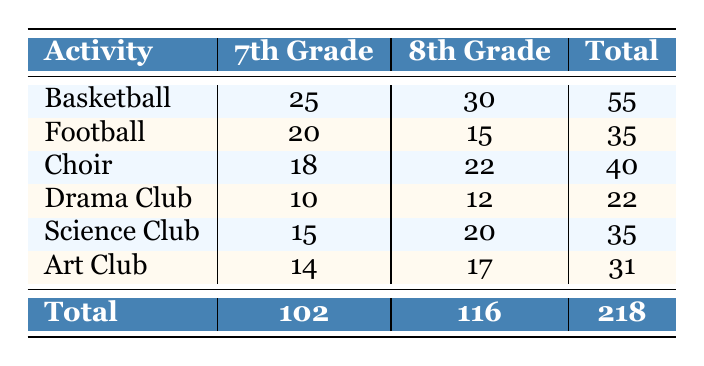What is the total participation count for the Basketball activity? To find the total participation count for Basketball, refer to the table and find the values for both grades. In the 7th grade, the participation count is 25, and in the 8th grade, it is 30. Therefore, the total participation count is 25 + 30 = 55.
Answer: 55 How many students in total participated in extracurricular activities in the 7th Grade? To find the total participation count for the 7th Grade, sum up the participation counts for all listed activities at that grade level. The counts are: Basketball (25), Football (20), Choir (18), Drama Club (10), Science Club (15), and Art Club (14). Adding these gives 25 + 20 + 18 + 10 + 15 + 14 = 102.
Answer: 102 Is there more total participation in the 8th Grade compared to the 7th Grade? To determine this, compare the total participation counts for both grades. The total for the 8th Grade is 116, and for the 7th Grade, it is 102. Since 116 is greater than 102, the statement is true.
Answer: Yes What is the average participation count for the Drama Club across both grades? To calculate the average, first find the total participation count for the Drama Club, which is 10 for 7th Grade and 12 for 8th Grade. The total is 10 + 12 = 22. There are 2 grades, so to find the average, divide by 2: 22 / 2 = 11.
Answer: 11 Which activity had the least participation in the 8th Grade? Look at the participation counts for the 8th Grade activities, which are Basketball (30), Football (15), Choir (22), Drama Club (12), Science Club (20), and Art Club (17). The lowest count is 12 for the Drama Club, making it the activity with the least participation.
Answer: Drama Club If you combine the participation counts of Soccer and Choir for the 7th Grade, what is the total? First, note that Soccer is not listed in the table, so it has a participation count of 0. Choir has a participation count of 18. Adding these gives 0 + 18 = 18.
Answer: 18 How many more students participated in the Science Club in the 8th Grade compared to the Drama Club in the same grade? Determine the participation counts: Science Club (20) and Drama Club (12) for 8th Grade. The difference is calculated as 20 - 12 = 8, indicating there were 8 more students in the Science Club.
Answer: 8 What is the combined participation total for the Art Club and Football in the 7th Grade? Look up the counts: Art Club (14) and Football (20) for the 7th Grade. Summing these gives 14 + 20 = 34 for the combined count.
Answer: 34 